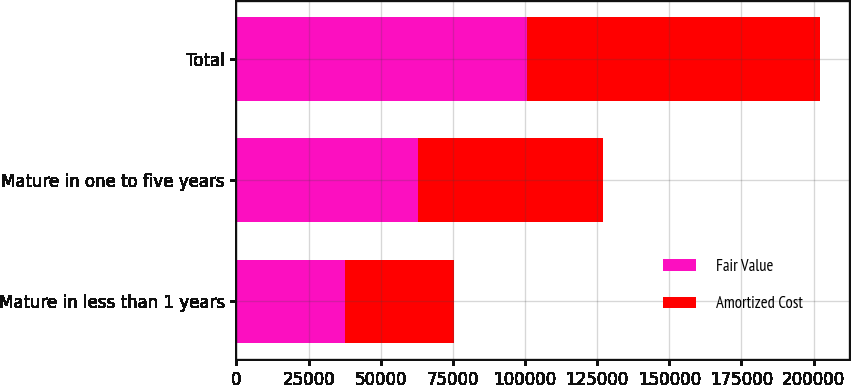Convert chart. <chart><loc_0><loc_0><loc_500><loc_500><stacked_bar_chart><ecel><fcel>Mature in less than 1 years<fcel>Mature in one to five years<fcel>Total<nl><fcel>Fair Value<fcel>37613<fcel>63062<fcel>100675<nl><fcel>Amortized Cost<fcel>37735<fcel>63879<fcel>101614<nl></chart> 